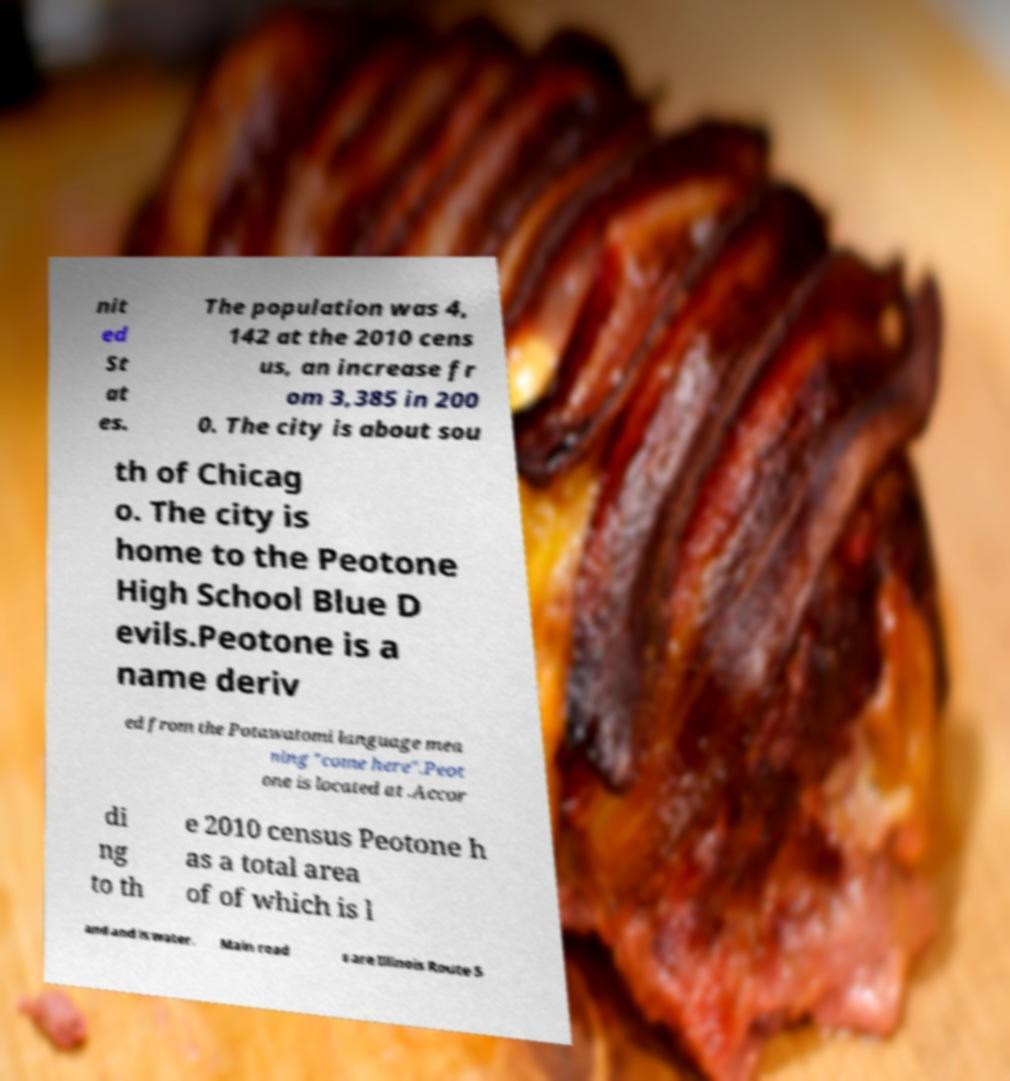For documentation purposes, I need the text within this image transcribed. Could you provide that? nit ed St at es. The population was 4, 142 at the 2010 cens us, an increase fr om 3,385 in 200 0. The city is about sou th of Chicag o. The city is home to the Peotone High School Blue D evils.Peotone is a name deriv ed from the Potawatomi language mea ning "come here".Peot one is located at .Accor di ng to th e 2010 census Peotone h as a total area of of which is l and and is water. Main road s are Illinois Route 5 